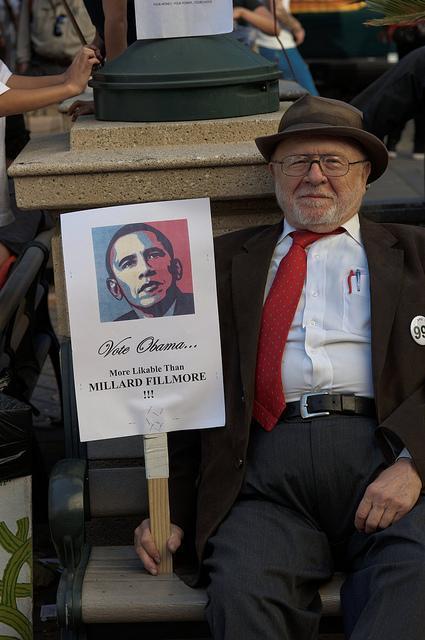How many people are there?
Give a very brief answer. 7. How many giraffes are shown?
Give a very brief answer. 0. 